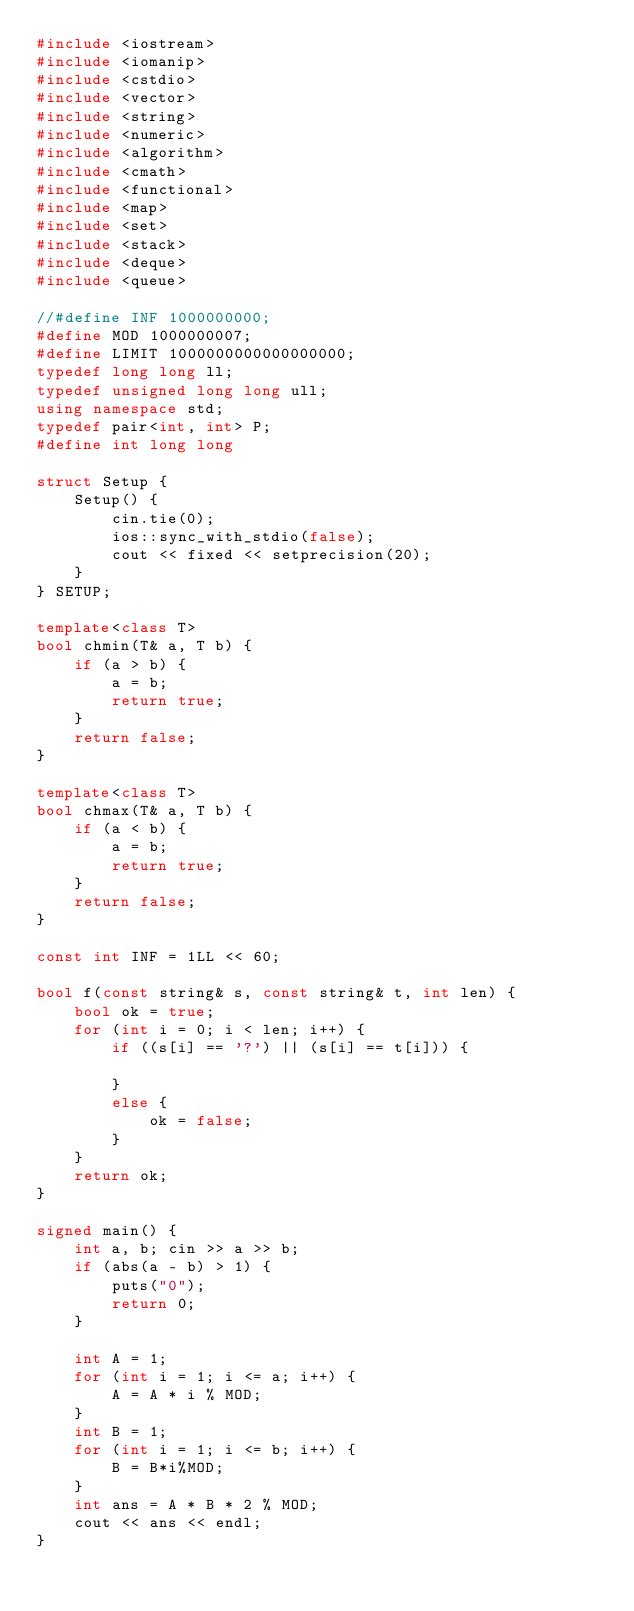Convert code to text. <code><loc_0><loc_0><loc_500><loc_500><_C++_>#include <iostream>
#include <iomanip>
#include <cstdio>
#include <vector>
#include <string>
#include <numeric>
#include <algorithm>
#include <cmath>
#include <functional>
#include <map>
#include <set>
#include <stack>
#include <deque>
#include <queue>

//#define INF 1000000000;
#define MOD 1000000007;
#define LIMIT 1000000000000000000;
typedef long long ll;
typedef unsigned long long ull;
using namespace std;
typedef pair<int, int> P;
#define int long long

struct Setup {
    Setup() {
        cin.tie(0);
        ios::sync_with_stdio(false);
        cout << fixed << setprecision(20);
    }
} SETUP;

template<class T>
bool chmin(T& a, T b) {
    if (a > b) {
        a = b;
        return true;
    }
    return false;
}

template<class T>
bool chmax(T& a, T b) {
    if (a < b) {
        a = b;
        return true;
    }
    return false;
}

const int INF = 1LL << 60;

bool f(const string& s, const string& t, int len) {
    bool ok = true;
    for (int i = 0; i < len; i++) {
        if ((s[i] == '?') || (s[i] == t[i])) {

        }
        else {
            ok = false;
        }
    }
    return ok;
}

signed main() {
    int a, b; cin >> a >> b;
    if (abs(a - b) > 1) {
        puts("0");
        return 0;
    }

    int A = 1;
    for (int i = 1; i <= a; i++) {
        A = A * i % MOD;
    }
    int B = 1;
    for (int i = 1; i <= b; i++) {
        B = B*i%MOD;
    }
    int ans = A * B * 2 % MOD;
    cout << ans << endl;
}</code> 